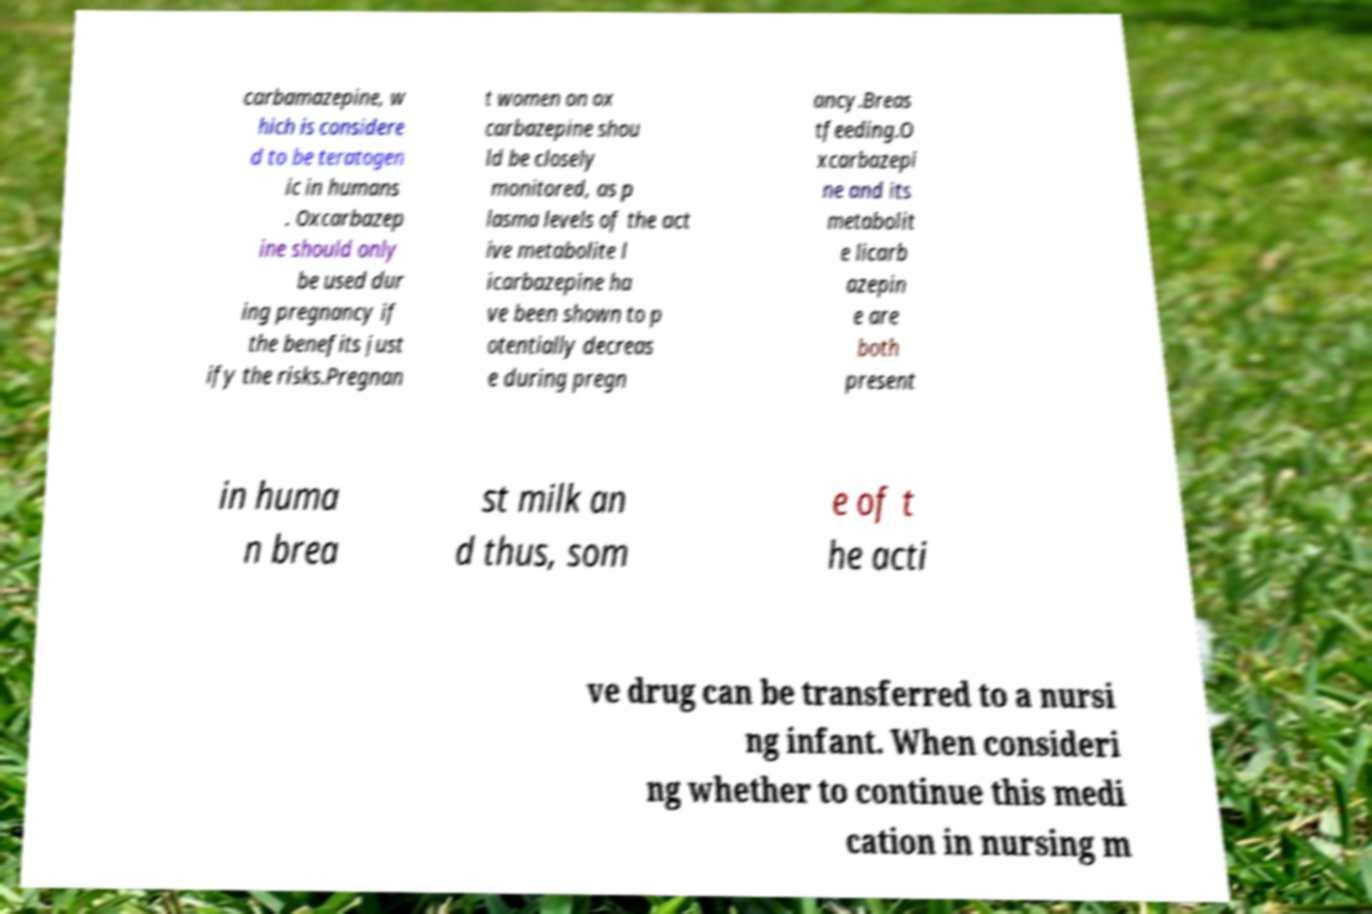Please identify and transcribe the text found in this image. carbamazepine, w hich is considere d to be teratogen ic in humans . Oxcarbazep ine should only be used dur ing pregnancy if the benefits just ify the risks.Pregnan t women on ox carbazepine shou ld be closely monitored, as p lasma levels of the act ive metabolite l icarbazepine ha ve been shown to p otentially decreas e during pregn ancy.Breas tfeeding.O xcarbazepi ne and its metabolit e licarb azepin e are both present in huma n brea st milk an d thus, som e of t he acti ve drug can be transferred to a nursi ng infant. When consideri ng whether to continue this medi cation in nursing m 